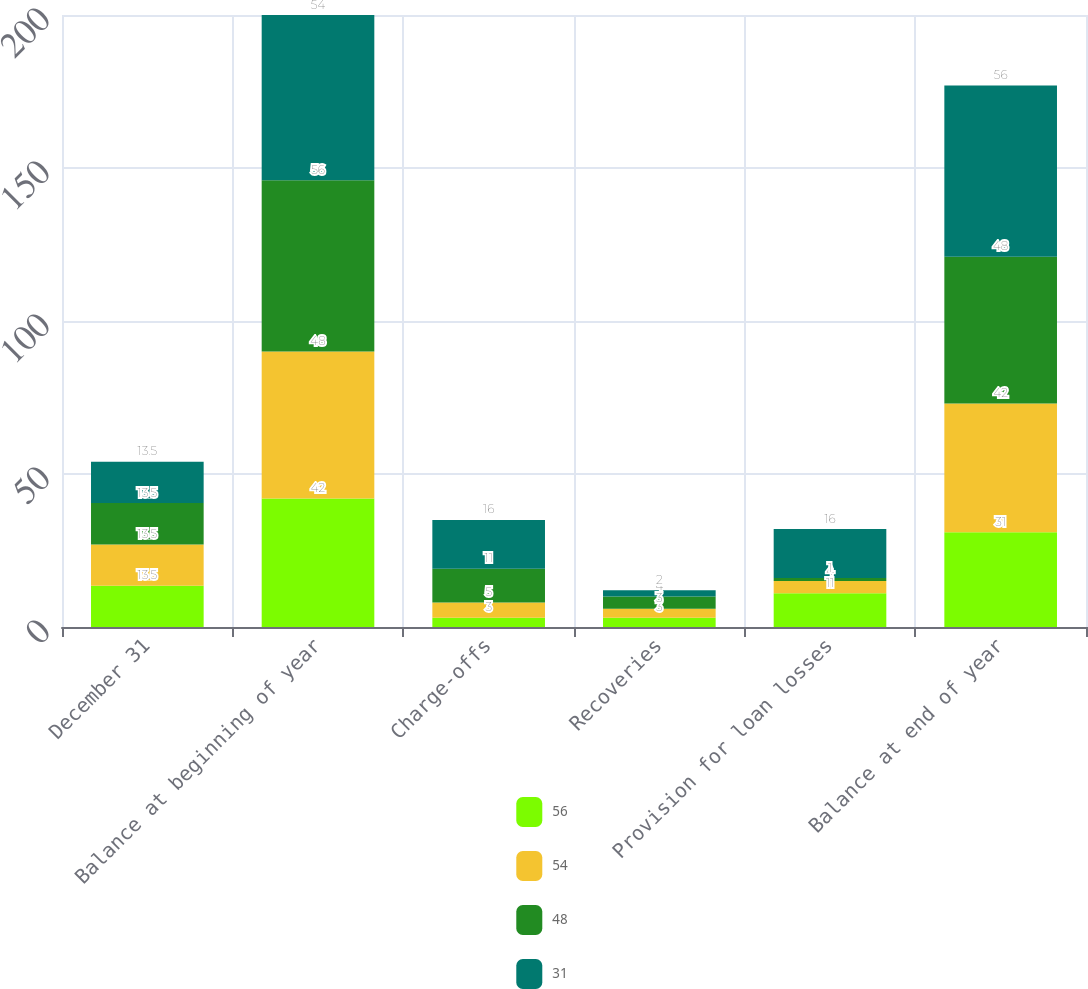<chart> <loc_0><loc_0><loc_500><loc_500><stacked_bar_chart><ecel><fcel>December 31<fcel>Balance at beginning of year<fcel>Charge-offs<fcel>Recoveries<fcel>Provision for loan losses<fcel>Balance at end of year<nl><fcel>56<fcel>13.5<fcel>42<fcel>3<fcel>3<fcel>11<fcel>31<nl><fcel>54<fcel>13.5<fcel>48<fcel>5<fcel>3<fcel>4<fcel>42<nl><fcel>48<fcel>13.5<fcel>56<fcel>11<fcel>4<fcel>1<fcel>48<nl><fcel>31<fcel>13.5<fcel>54<fcel>16<fcel>2<fcel>16<fcel>56<nl></chart> 